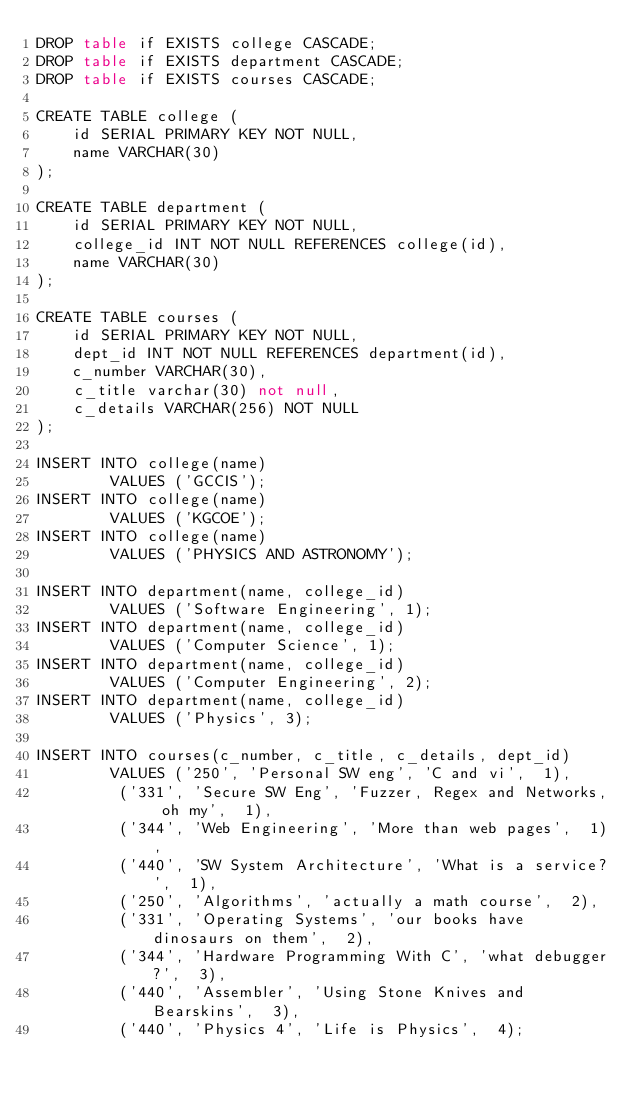<code> <loc_0><loc_0><loc_500><loc_500><_SQL_>DROP table if EXISTS college CASCADE;
DROP table if EXISTS department CASCADE;
DROP table if EXISTS courses CASCADE;

CREATE TABLE college (
    id SERIAL PRIMARY KEY NOT NULL,
    name VARCHAR(30)
);

CREATE TABLE department (
    id SERIAL PRIMARY KEY NOT NULL,
    college_id INT NOT NULL REFERENCES college(id),
    name VARCHAR(30)
);

CREATE TABLE courses (
    id SERIAL PRIMARY KEY NOT NULL,
    dept_id INT NOT NULL REFERENCES department(id),
    c_number VARCHAR(30),
    c_title varchar(30) not null,
    c_details VARCHAR(256) NOT NULL
);

INSERT INTO college(name)	
        VALUES ('GCCIS');
INSERT INTO college(name)	
        VALUES ('KGCOE');
INSERT INTO college(name)	
        VALUES ('PHYSICS AND ASTRONOMY');
		
INSERT INTO department(name, college_id)	
        VALUES ('Software Engineering', 1);
INSERT INTO department(name, college_id)	
        VALUES ('Computer Science', 1);
INSERT INTO department(name, college_id)	
        VALUES ('Computer Engineering', 2);
INSERT INTO department(name, college_id)	
        VALUES ('Physics', 3);

INSERT INTO courses(c_number, c_title, c_details, dept_id)	
        VALUES ('250', 'Personal SW eng', 'C and vi',  1),	
         ('331', 'Secure SW Eng', 'Fuzzer, Regex and Networks, oh my',  1),
         ('344', 'Web Engineering', 'More than web pages',  1),
         ('440', 'SW System Architecture', 'What is a service?',  1),
         ('250', 'Algorithms', 'actually a math course',  2),
         ('331', 'Operating Systems', 'our books have dinosaurs on them',  2),
         ('344', 'Hardware Programming With C', 'what debugger?',  3),
         ('440', 'Assembler', 'Using Stone Knives and Bearskins',  3),
         ('440', 'Physics 4', 'Life is Physics',  4);</code> 